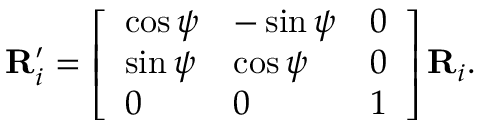Convert formula to latex. <formula><loc_0><loc_0><loc_500><loc_500>R _ { i } ^ { \prime } = \left [ \begin{array} { l l l } { \cos { \psi } } & { - \sin { \psi } } & { 0 } \\ { \sin { \psi } } & { \cos { \psi } } & { 0 } \\ { 0 } & { 0 } & { 1 } \end{array} \right ] R _ { i } .</formula> 